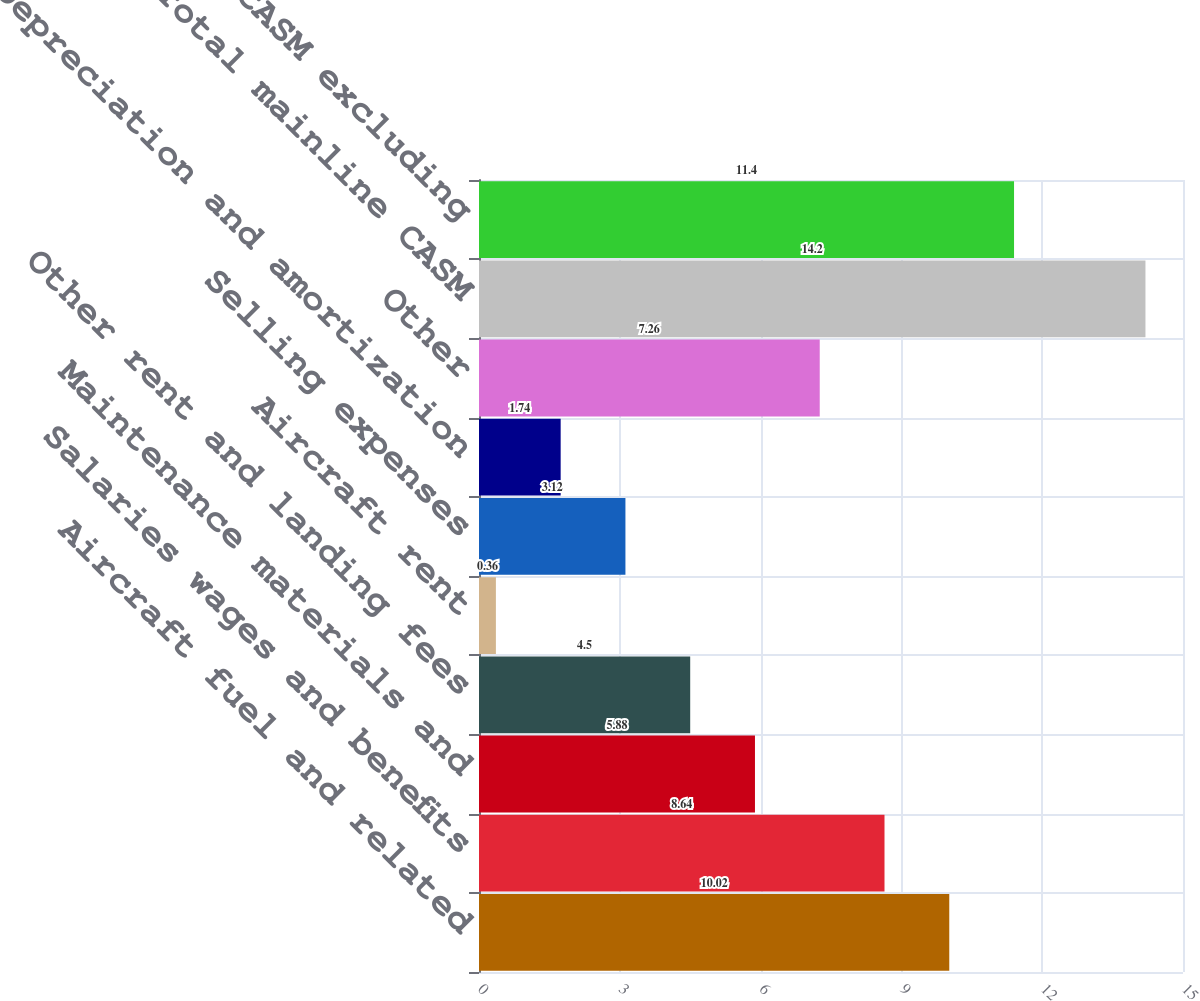Convert chart. <chart><loc_0><loc_0><loc_500><loc_500><bar_chart><fcel>Aircraft fuel and related<fcel>Salaries wages and benefits<fcel>Maintenance materials and<fcel>Other rent and landing fees<fcel>Aircraft rent<fcel>Selling expenses<fcel>Depreciation and amortization<fcel>Other<fcel>Total mainline CASM<fcel>Total mainline CASM excluding<nl><fcel>10.02<fcel>8.64<fcel>5.88<fcel>4.5<fcel>0.36<fcel>3.12<fcel>1.74<fcel>7.26<fcel>14.2<fcel>11.4<nl></chart> 